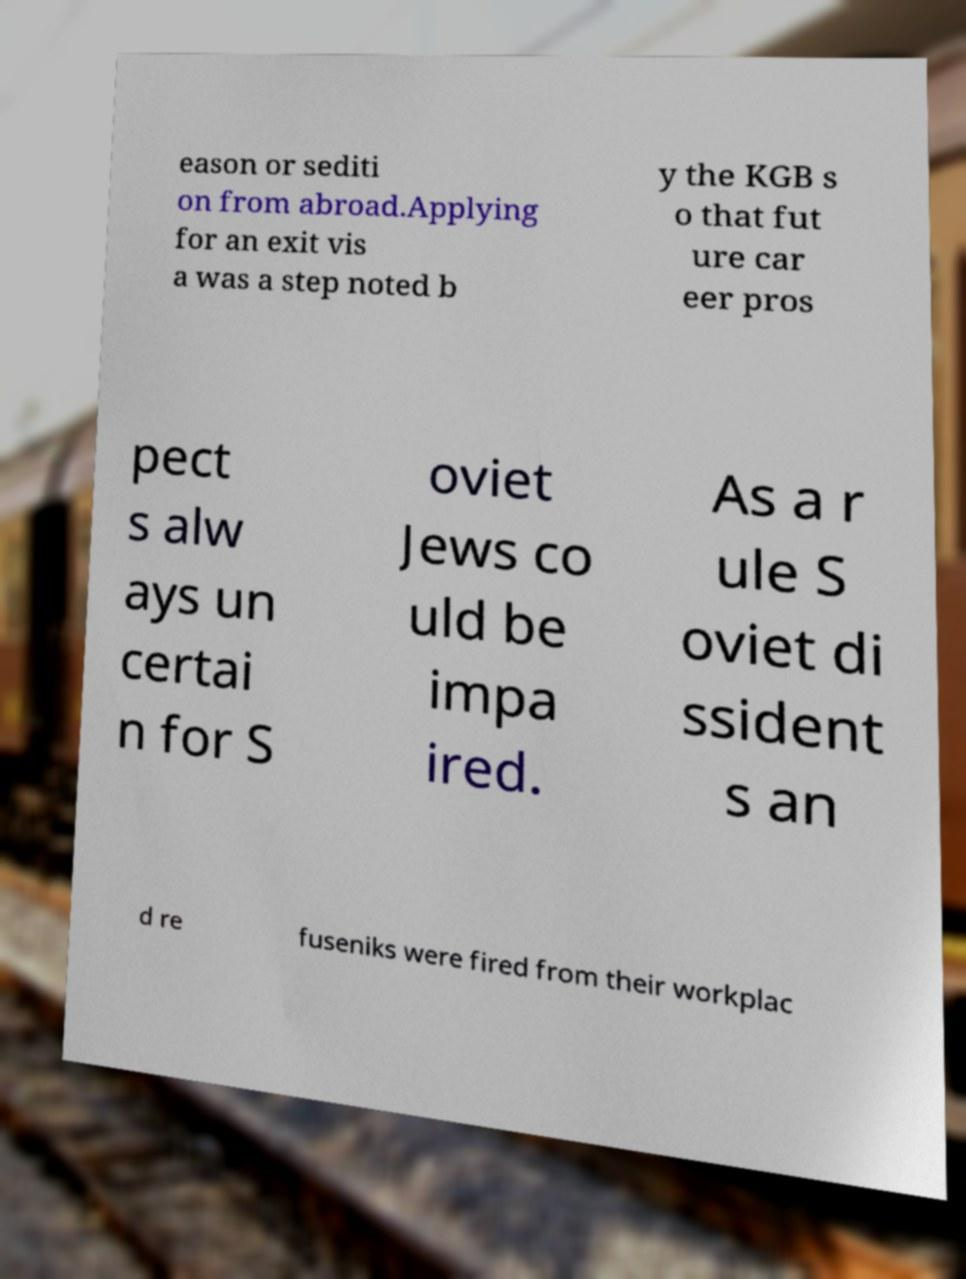Could you extract and type out the text from this image? eason or sediti on from abroad.Applying for an exit vis a was a step noted b y the KGB s o that fut ure car eer pros pect s alw ays un certai n for S oviet Jews co uld be impa ired. As a r ule S oviet di ssident s an d re fuseniks were fired from their workplac 